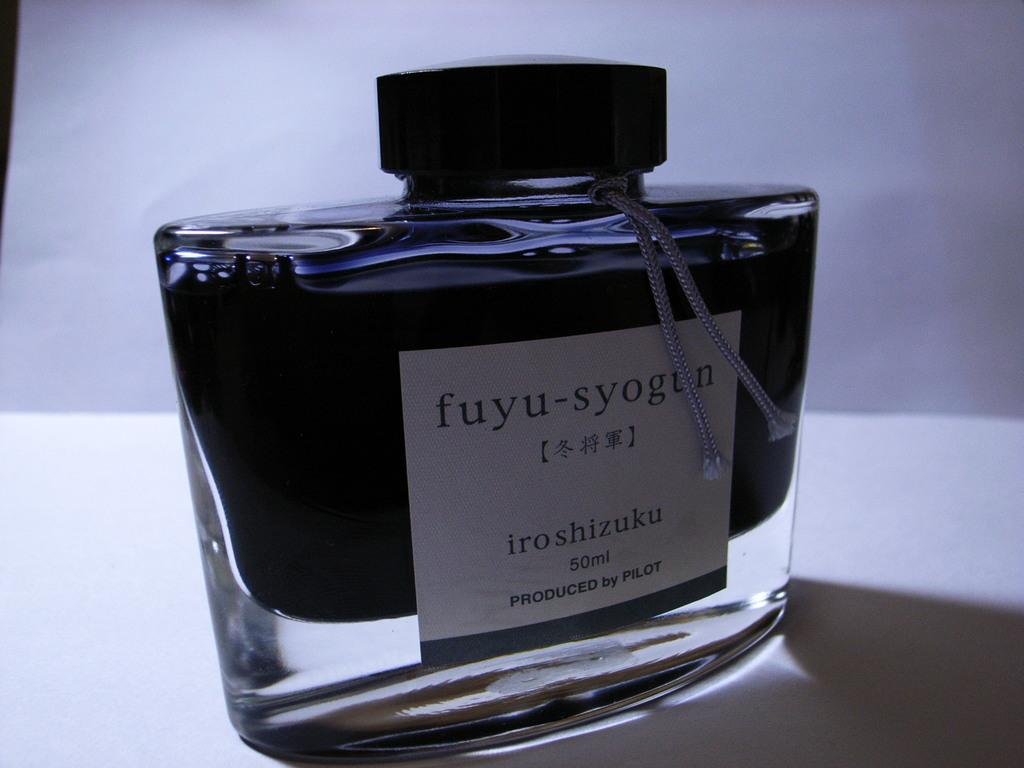Who produced this product?
Offer a very short reply. Pilot. What kind of  product is this?
Your response must be concise. Perfume. 